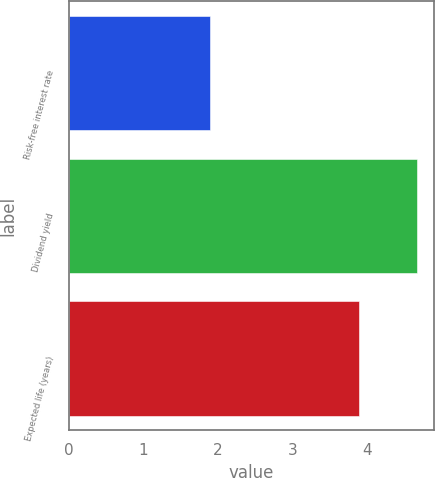Convert chart. <chart><loc_0><loc_0><loc_500><loc_500><bar_chart><fcel>Risk-free interest rate<fcel>Dividend yield<fcel>Expected life (years)<nl><fcel>1.9<fcel>4.67<fcel>3.9<nl></chart> 